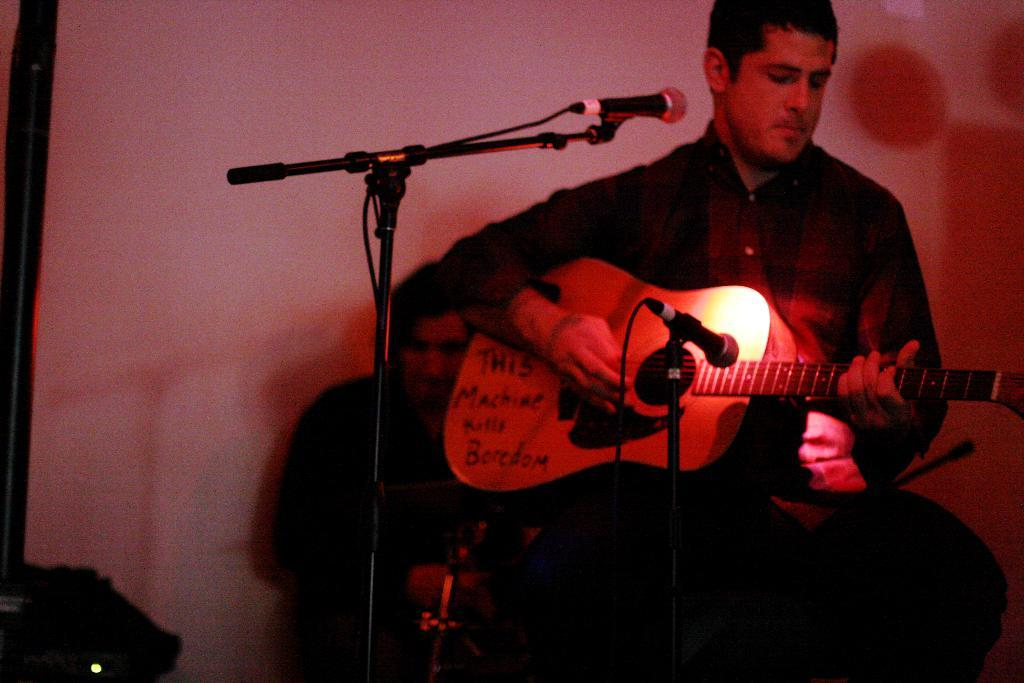Who is the person in the image? There is a man in the image. What is the man doing in the image? The man is sitting and playing a guitar. What object is present for amplifying sound in the image? There is a microphone in the image. What can be seen in the background of the image? There is a wall in the background of the image. What is the current temperature in the room where the man is playing the guitar? The provided facts do not mention the temperature in the room, so it cannot be determined from the image. 